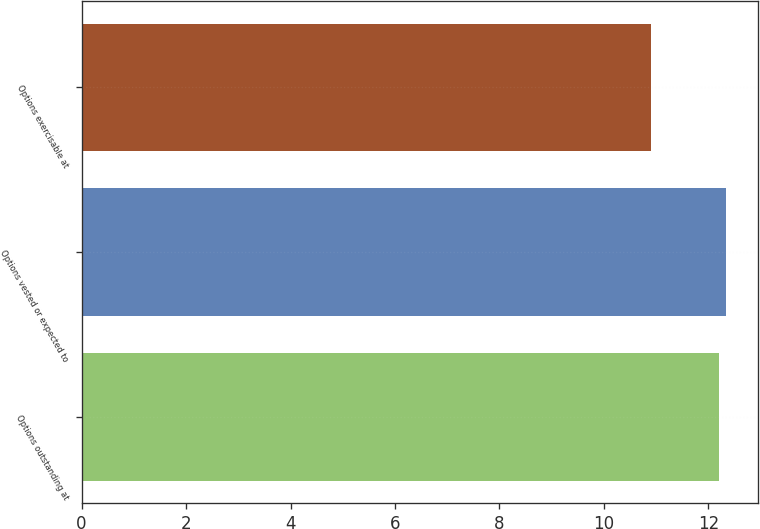<chart> <loc_0><loc_0><loc_500><loc_500><bar_chart><fcel>Options outstanding at<fcel>Options vested or expected to<fcel>Options exercisable at<nl><fcel>12.2<fcel>12.33<fcel>10.9<nl></chart> 